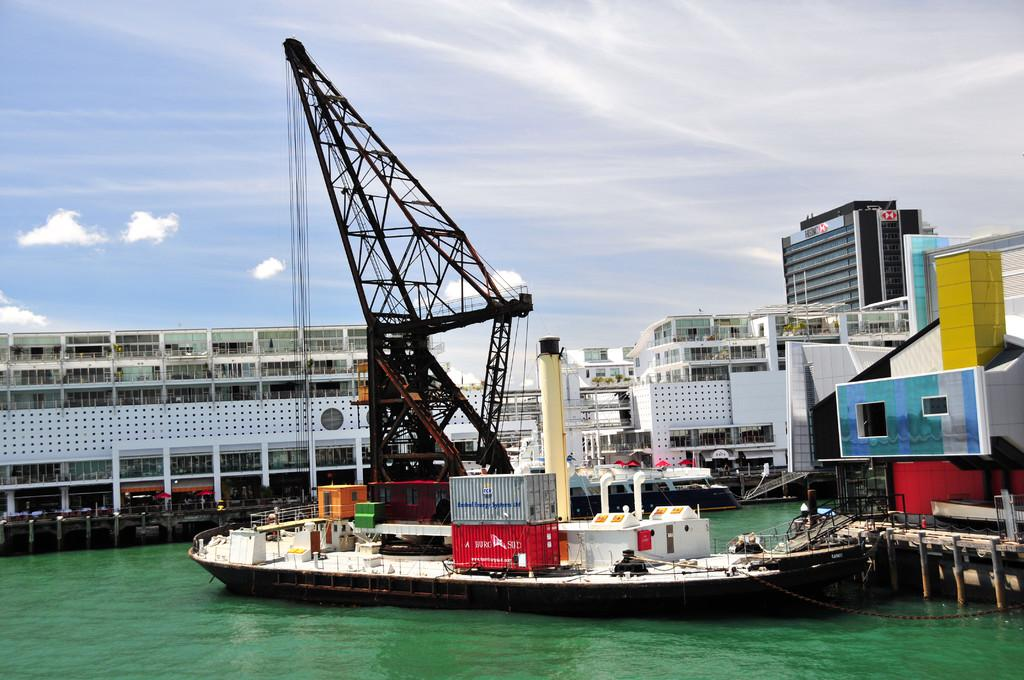What type of location is depicted in the image? There is a harbor in the image. What natural feature is present in the image? There is a sea in the image. What type of vehicle can be seen in the image? There is a watercraft in the image. What type of man-made structures are visible in the image? There are buildings in the image. How would you describe the sky in the image? The sky is blue and cloudy in the image. What type of soap is being used to clean the cow in the image? There is no cow or soap present in the image. 